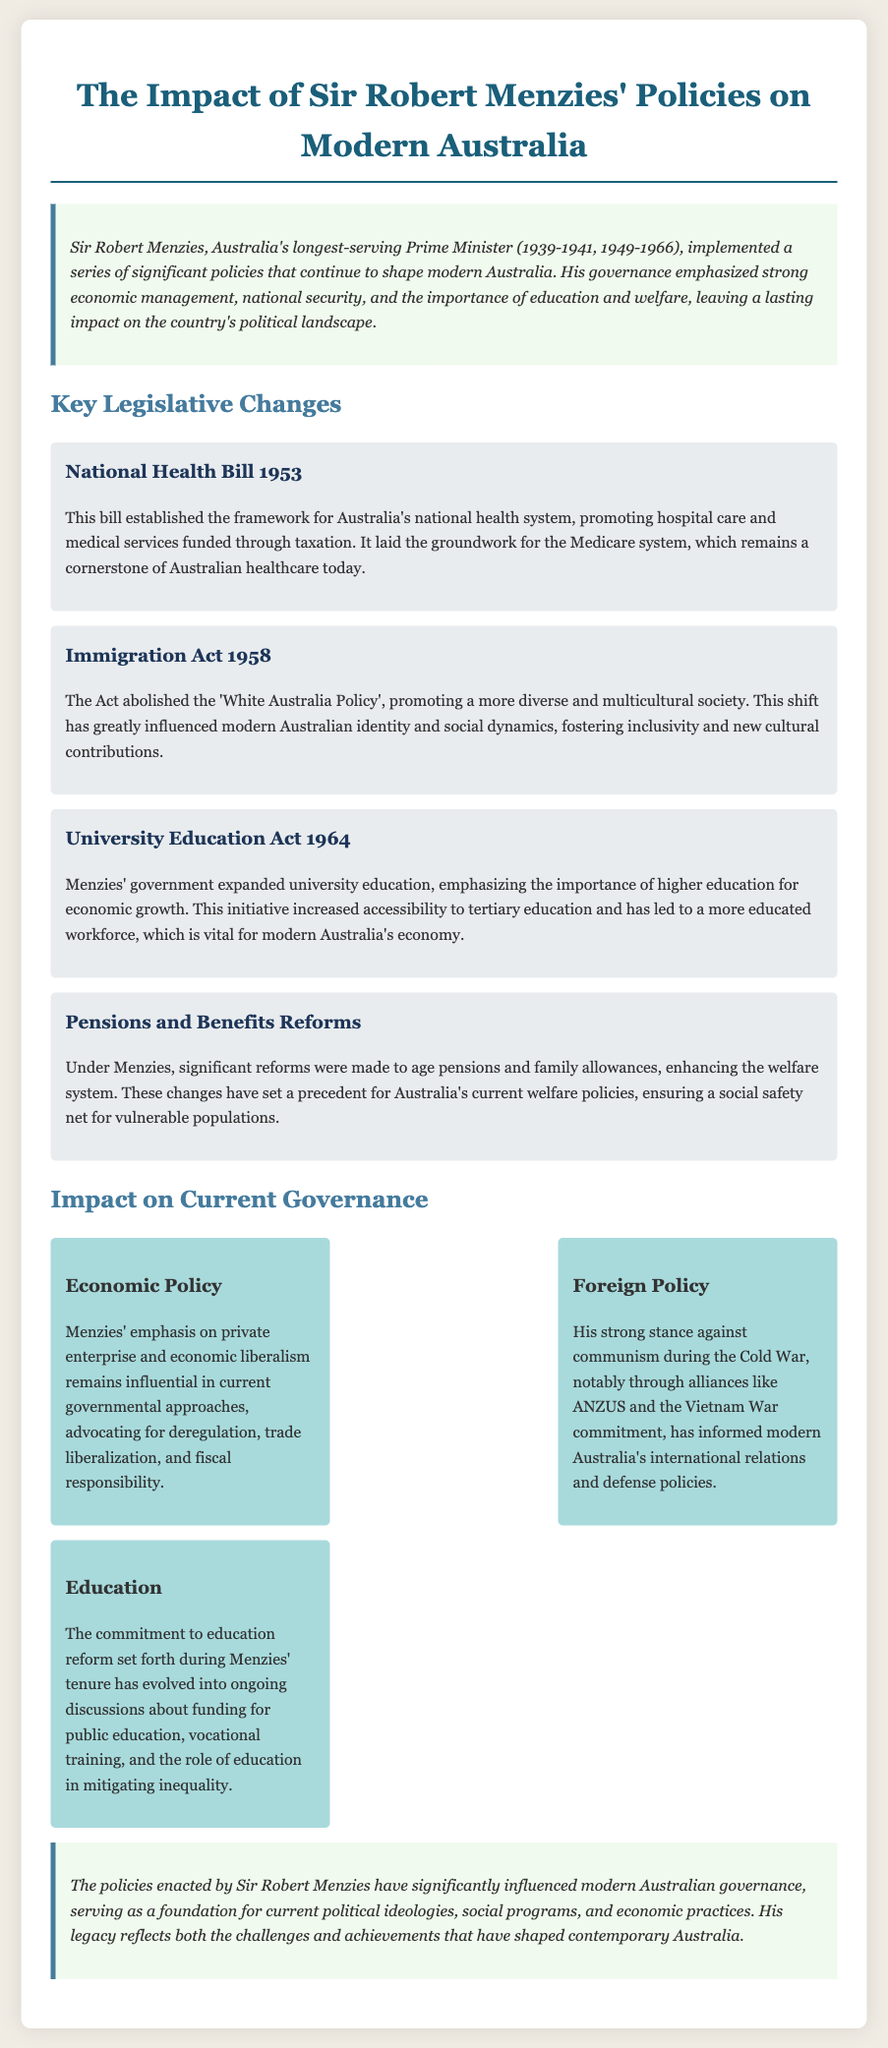What was the tenure of Sir Robert Menzies as Prime Minister? Sir Robert Menzies served as Prime Minister from 1939 to 1941 and again from 1949 to 1966.
Answer: 1939-1941, 1949-1966 What is the key feature of the National Health Bill 1953? The National Health Bill 1953 established the framework for Australia's national health system, promoting hospital care and medical services funded through taxation.
Answer: National health system What significant policy was abolished by the Immigration Act 1958? The Immigration Act 1958 abolished the 'White Australia Policy', promoting a more diverse and multicultural society.
Answer: 'White Australia Policy' What year was the University Education Act enacted? The University Education Act was enacted in 1964, expanding university education in Australia.
Answer: 1964 What impact did Menzies' policies have on modern economic policy? Menzies' policies emphasized private enterprise and economic liberalism, which remains influential in current governmental approaches.
Answer: Private enterprise, economic liberalism What cultural shift did the Immigration Act 1958 promote in Australia? The Immigration Act 1958 promoted a more diverse and multicultural society, influencing modern Australian identity.
Answer: Multicultural society What was the consequence of Menzies' reforms to age pensions? The reforms enhanced the welfare system, ensuring a social safety net for vulnerable populations.
Answer: Social safety net What ongoing debate relates to the education reforms initiated during Menzies' tenure? The ongoing discussions relate to funding for public education and the role of education in mitigating inequality.
Answer: Funding for public education Which policy area did Menzies significantly influence concerning international relations? Menzies' strong stance against communism and alliances like ANZUS have informed modern Australia's international relations and defense policies.
Answer: International relations and defense policies 